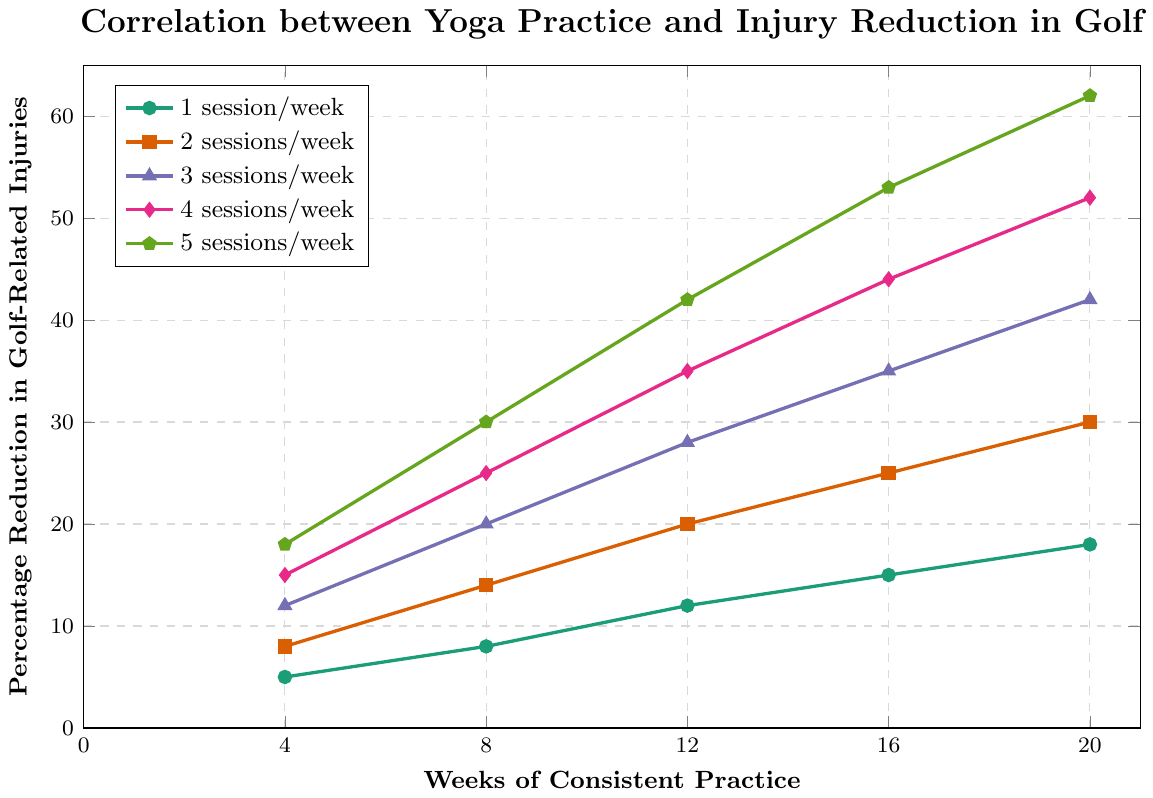What is the percentage reduction in golf-related injuries after 20 weeks of practicing yoga 3 times per week? Look at the line representing 3 sessions/week (marked with triangles). Find the value at 20 weeks on the x-axis, which corresponds to 42% on the y-axis.
Answer: 42% Which yoga frequency shows the greatest reduction in injuries after 8 weeks? Compare the values on the y-axis at 8 weeks for all lines. The line representing 5 sessions/week (pentagon markers) reaches 30%, the highest among all.
Answer: 5 sessions/week What's the average reduction in golf-related injuries at 4 weeks across all yoga frequencies? Look at the values on the y-axis at 4 weeks for all lines: 5, 8, 12, 15, and 18. The average is (5 + 8 + 12 + 15 + 18) / 5 = 58 / 5 = 11.6%.
Answer: 11.6% Between which weeks does the most significant increase in injury reduction occur for practicing yoga 4 times per week? Examine the increments on the line for 4 sessions/week (diamond markers). The biggest increase is from 12 weeks (35%) to 16 weeks (44%), an increase of 9%.
Answer: 12 to 16 weeks Which session frequency shows a consistent linear increase in injury reduction? Inspect the lines closely; all show an upward trend, but 3 sessions/week (triangle markers) approximates a linear increase most closely.
Answer: 3 sessions/week By how much does the injury reduction percentage increase from 12 weeks to 20 weeks for practicing yoga 2 times per week? For 2 sessions/week (square markers), note the values: 20% at 12 weeks and 30% at 20 weeks, resulting in an increase of 30% - 20% = 10%.
Answer: 10% How does the percentage reduction in injuries compare between 1 session/week and 5 sessions/week at 16 weeks? Check the y-axis values at 16 weeks for both lines: 15% for 1 session/week (circle markers) and 53% for 5 sessions/week (pentagon markers). 53% - 15% = 38%.
Answer: 5 sessions/week shows a 38% higher reduction What is the trend in injury reduction for practicing yoga 1 time per week over the 20 weeks? Look at the line for 1 session/week (circle markers). The trend shows a steady, gradual increase from 5% at 4 weeks to 18% at 20 weeks.
Answer: Steady, gradual increase 